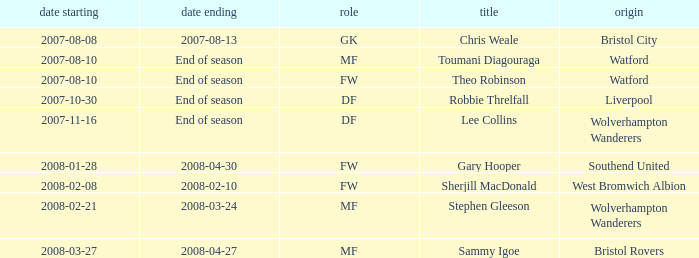What was the Date From for Theo Robinson, who was with the team until the end of season? 2007-08-10. 